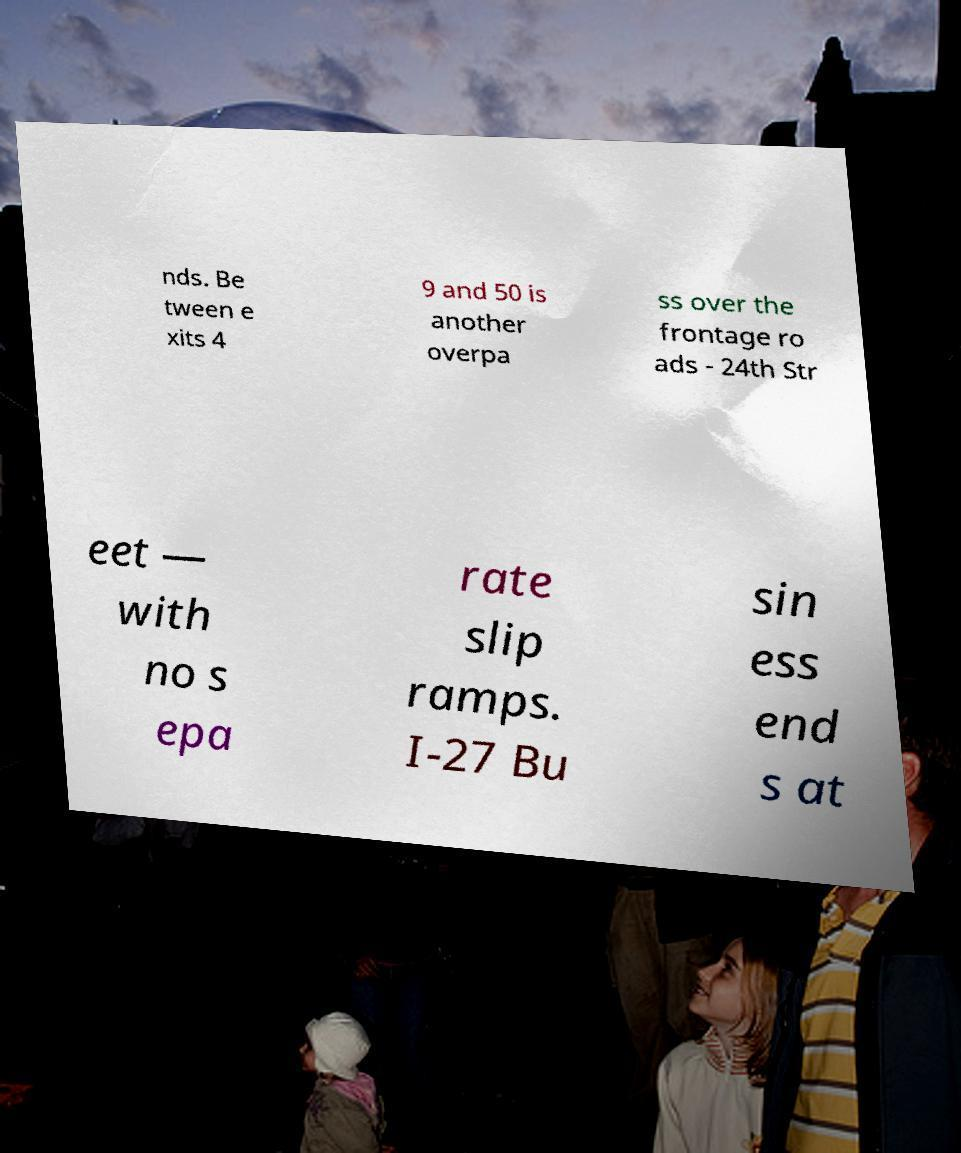Could you assist in decoding the text presented in this image and type it out clearly? nds. Be tween e xits 4 9 and 50 is another overpa ss over the frontage ro ads - 24th Str eet — with no s epa rate slip ramps. I-27 Bu sin ess end s at 